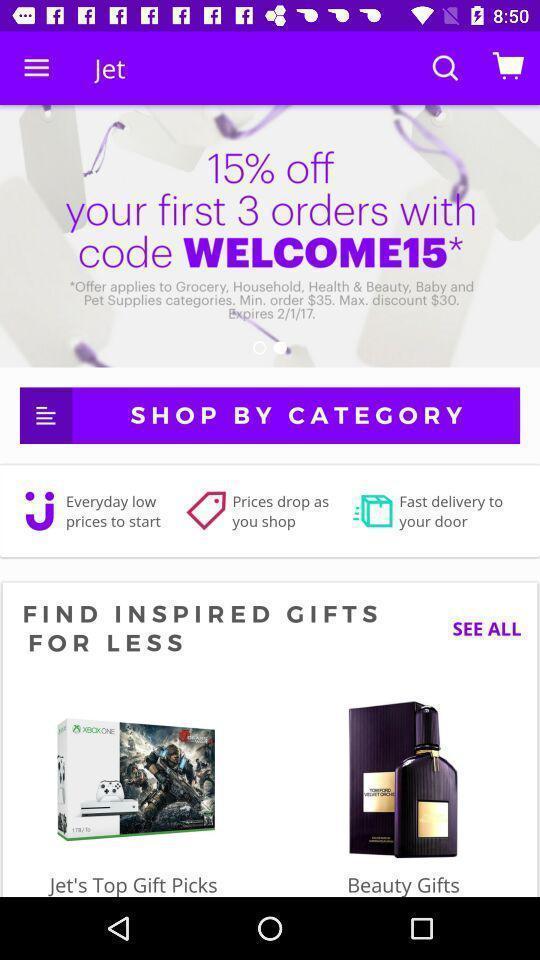What can you discern from this picture? Search results page displayed of a online shopping app. 